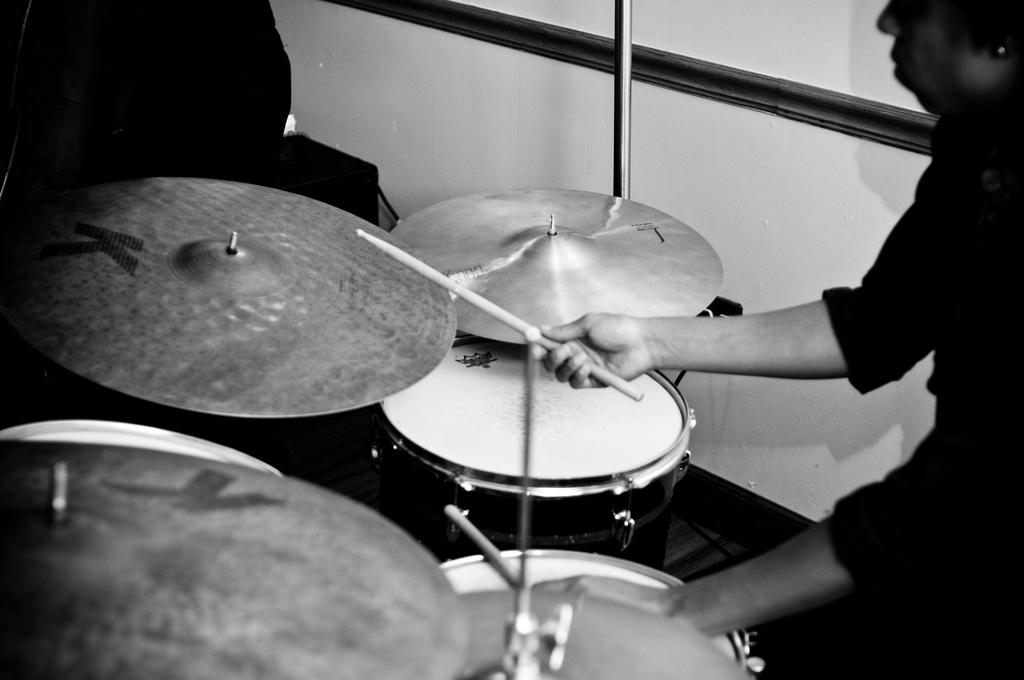What is the main subject of the image? The main subject of the image is a man. What is the man doing in the image? The man is playing a musical instrument in the image. What type of watch is the man wearing in the image? There is no watch visible in the image. What drink is the man holding in the image? There is no drink present in the image. 